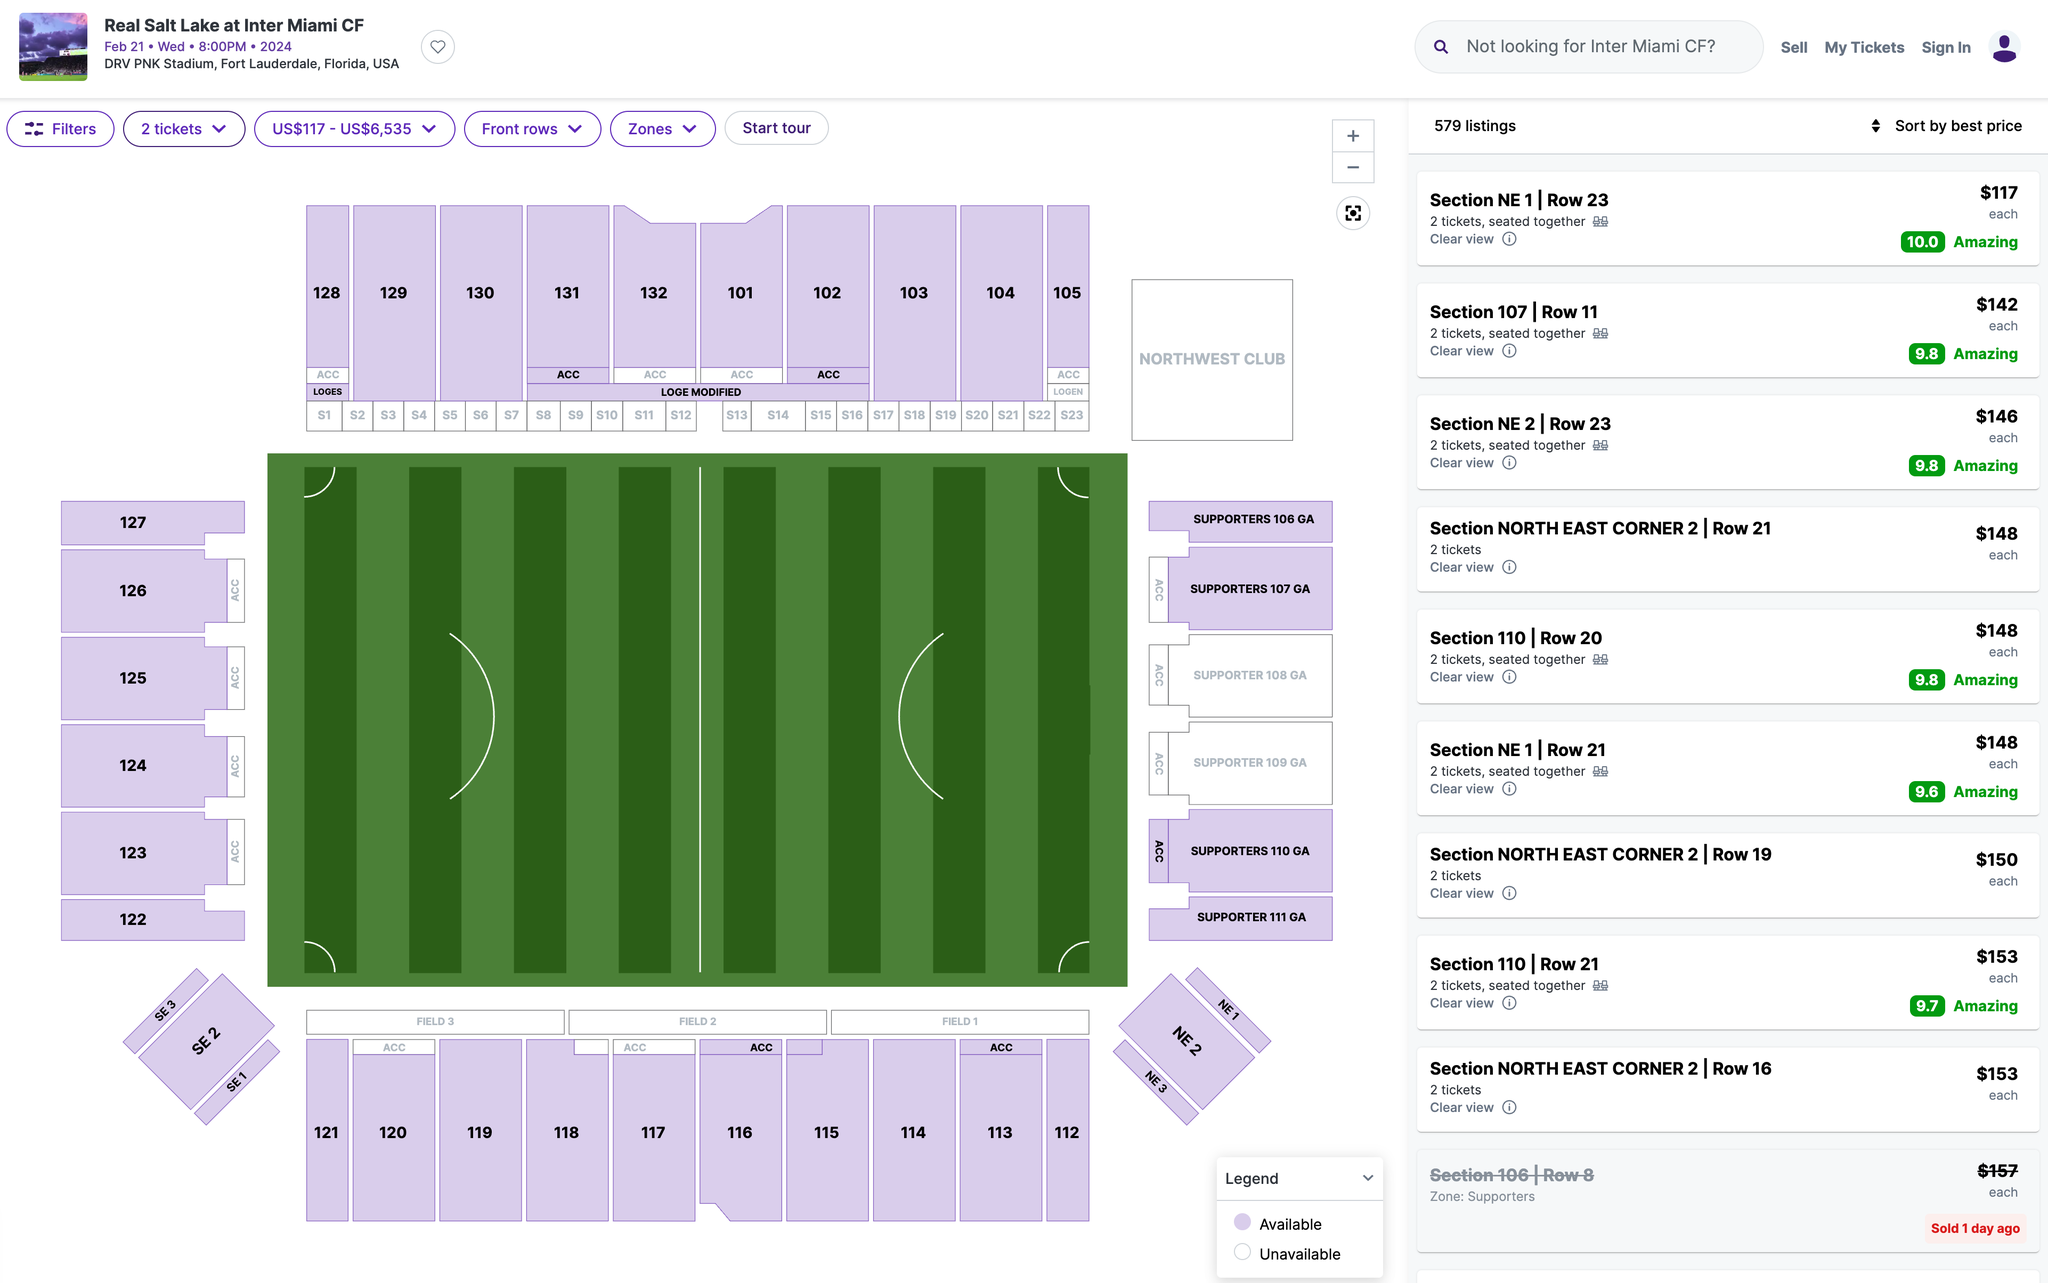please help me edit the english setences: There is no Table 5 in our submitted manuscript. We assumed that the Reviewer was talking about Figure 5.

We created a new version of Figure 5 depicting the bar graphs with adjusted OR values and 95% CI. We have provided additional details on the Figure 5 in the method and result sections, including data curation and how odd ratios were obtained (especially the reference group) in Page 10, Paragraph 1, 2 and Page 11, Paragraph 2. There is no Table 5 in our submitted manuscript. We assumed that the Reviewer was talking about Figure 5.

We created a new version of Figure 5 depicting the bar graphs with adjusted OR values and 95% CI. We have provided additional details on the Figure 5 in the method and result sections, including data curation and how odd ratios were obtained (especially the reference group) in Page 10, Paragraph 1, 2 and Page 11, Paragraph 2. 